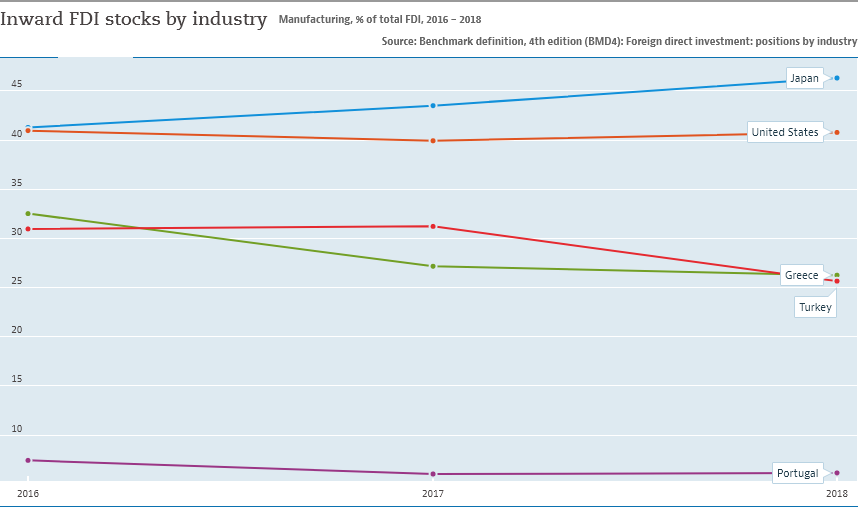Mention a couple of crucial points in this snapshot. In all years, the lowest amount of Inward FDI stocks by industry was shown by Portugal, indicating a weak investment inflow in the country's industries. In 2018, the stocks of Turkey went below the intersection with Greece. 